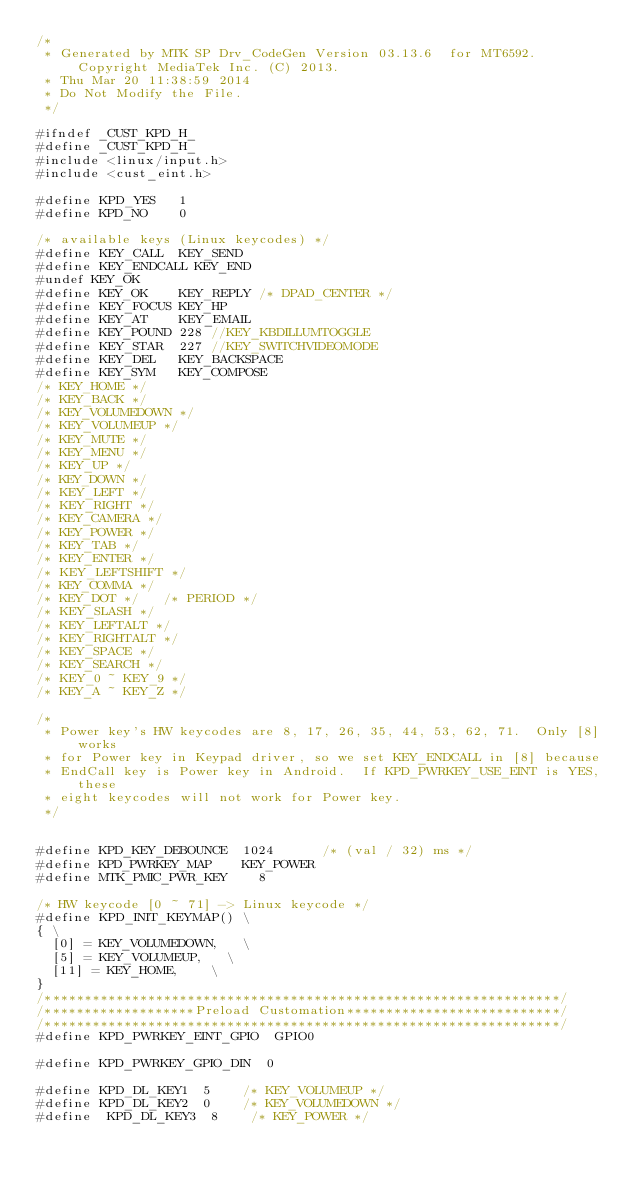Convert code to text. <code><loc_0><loc_0><loc_500><loc_500><_C_>/*
 * Generated by MTK SP Drv_CodeGen Version 03.13.6  for MT6592. Copyright MediaTek Inc. (C) 2013.
 * Thu Mar 20 11:38:59 2014
 * Do Not Modify the File.
 */

#ifndef _CUST_KPD_H_
#define _CUST_KPD_H_
#include <linux/input.h>
#include <cust_eint.h>

#define KPD_YES		1
#define KPD_NO		0

/* available keys (Linux keycodes) */
#define KEY_CALL	KEY_SEND
#define KEY_ENDCALL	KEY_END
#undef KEY_OK
#define KEY_OK		KEY_REPLY	/* DPAD_CENTER */
#define KEY_FOCUS	KEY_HP
#define KEY_AT		KEY_EMAIL
#define KEY_POUND	228	//KEY_KBDILLUMTOGGLE
#define KEY_STAR	227	//KEY_SWITCHVIDEOMODE
#define KEY_DEL 	KEY_BACKSPACE
#define KEY_SYM		KEY_COMPOSE
/* KEY_HOME */
/* KEY_BACK */
/* KEY_VOLUMEDOWN */
/* KEY_VOLUMEUP */
/* KEY_MUTE */
/* KEY_MENU */
/* KEY_UP */
/* KEY_DOWN */
/* KEY_LEFT */
/* KEY_RIGHT */
/* KEY_CAMERA */
/* KEY_POWER */
/* KEY_TAB */
/* KEY_ENTER */
/* KEY_LEFTSHIFT */
/* KEY_COMMA */
/* KEY_DOT */		/* PERIOD */
/* KEY_SLASH */
/* KEY_LEFTALT */
/* KEY_RIGHTALT */
/* KEY_SPACE */
/* KEY_SEARCH */
/* KEY_0 ~ KEY_9 */
/* KEY_A ~ KEY_Z */

/*
 * Power key's HW keycodes are 8, 17, 26, 35, 44, 53, 62, 71.  Only [8] works
 * for Power key in Keypad driver, so we set KEY_ENDCALL in [8] because
 * EndCall key is Power key in Android.  If KPD_PWRKEY_USE_EINT is YES, these
 * eight keycodes will not work for Power key.
 */


#define KPD_KEY_DEBOUNCE  1024      /* (val / 32) ms */
#define KPD_PWRKEY_MAP    KEY_POWER
#define MTK_PMIC_PWR_KEY    8

/* HW keycode [0 ~ 71] -> Linux keycode */
#define KPD_INIT_KEYMAP()	\
{	\
	[0] = KEY_VOLUMEDOWN,		\
	[5] = KEY_VOLUMEUP,		\
	[11] = KEY_HOME,		\
}	 
/*****************************************************************/
/*******************Preload Customation***************************/
/*****************************************************************/
#define KPD_PWRKEY_EINT_GPIO  GPIO0

#define KPD_PWRKEY_GPIO_DIN  0

#define KPD_DL_KEY1  5    /* KEY_VOLUMEUP */
#define KPD_DL_KEY2  0    /* KEY_VOLUMEDOWN */
#define  KPD_DL_KEY3  8    /* KEY_POWER */</code> 